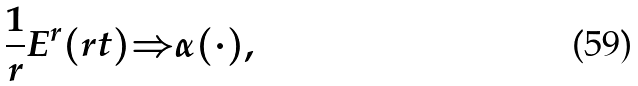<formula> <loc_0><loc_0><loc_500><loc_500>\frac { 1 } { r } E ^ { r } ( r t ) { \Rightarrow } \alpha ( \cdot ) ,</formula> 